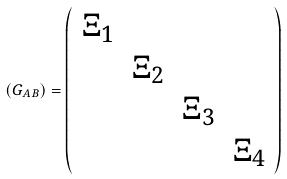Convert formula to latex. <formula><loc_0><loc_0><loc_500><loc_500>( G _ { A B } ) = \left ( \begin{array} { c c c c } \Xi _ { 1 } & & & \\ & \Xi _ { 2 } & & \\ & & \Xi _ { 3 } & \\ & & & \Xi _ { 4 } \end{array} \right )</formula> 